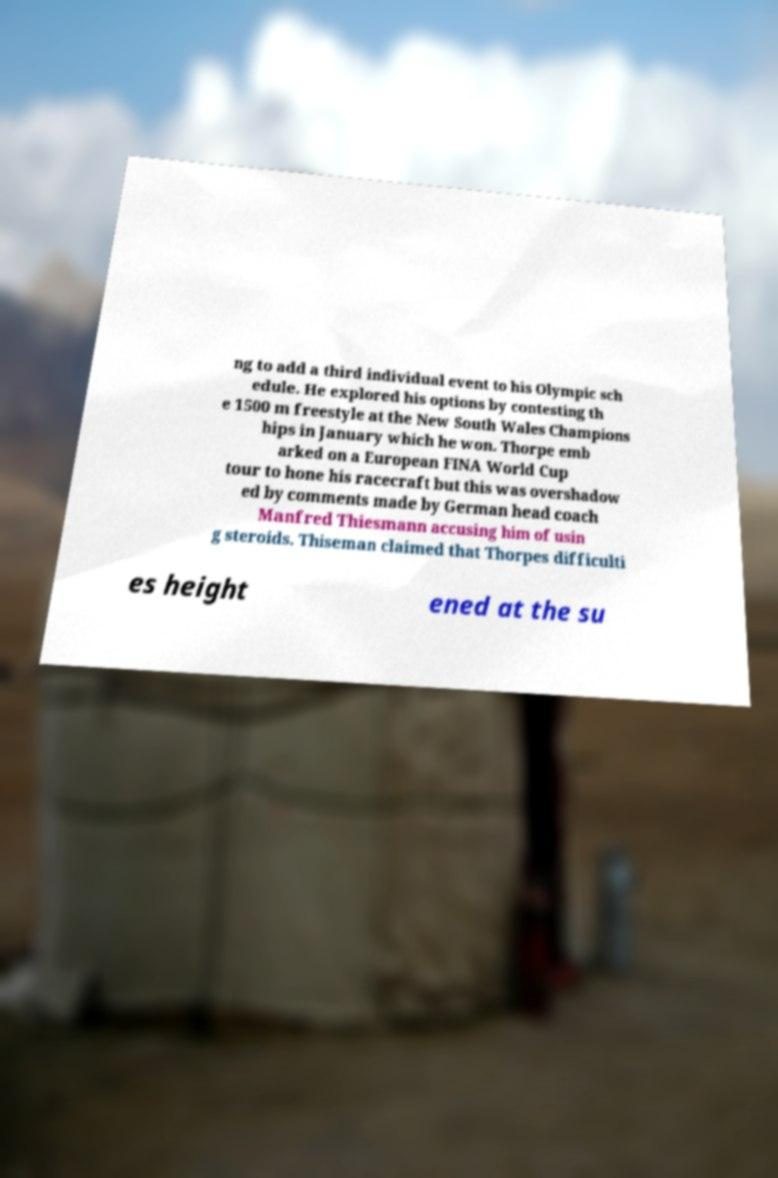For documentation purposes, I need the text within this image transcribed. Could you provide that? ng to add a third individual event to his Olympic sch edule. He explored his options by contesting th e 1500 m freestyle at the New South Wales Champions hips in January which he won. Thorpe emb arked on a European FINA World Cup tour to hone his racecraft but this was overshadow ed by comments made by German head coach Manfred Thiesmann accusing him of usin g steroids. Thiseman claimed that Thorpes difficulti es height ened at the su 